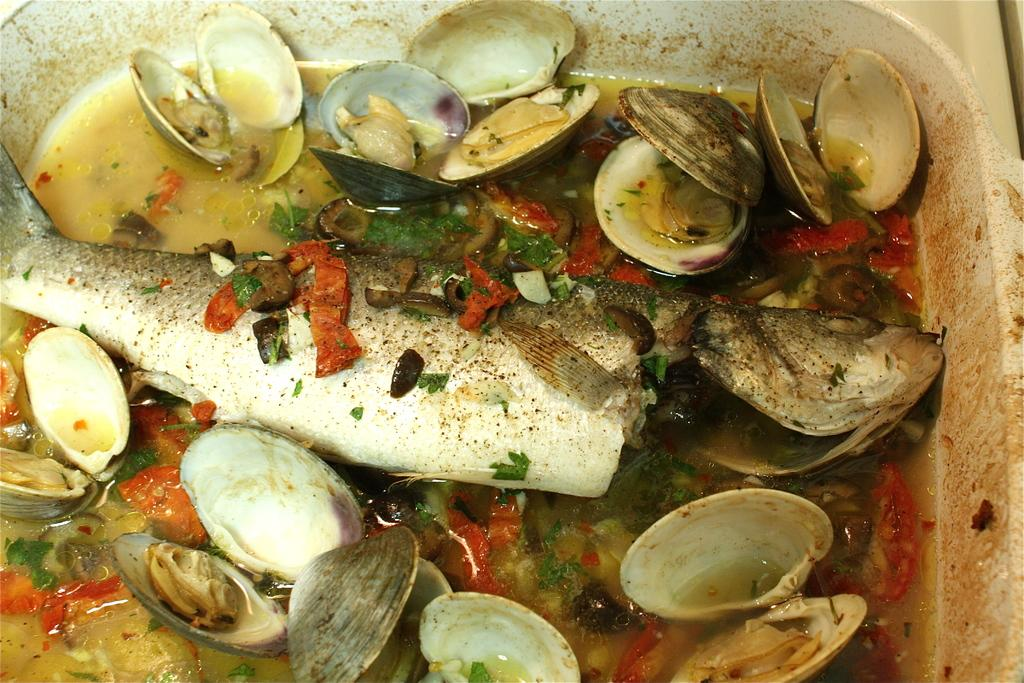What type of food is visible in the image? The food in the image contains a fish, shells, a tomato, and coriander leaves. How is the food arranged in the image? The food is arranged on a plate in the image. What type of crown is placed on top of the tomato in the image? There is no crown present on top of the tomato in the image. Can you describe the coat that the fish is wearing in the image? There is no coat present on the fish in the image. 